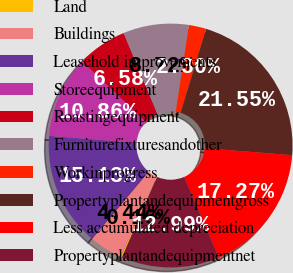Convert chart. <chart><loc_0><loc_0><loc_500><loc_500><pie_chart><fcel>Land<fcel>Buildings<fcel>Leasehold improvements<fcel>Storeequipment<fcel>Roastingequipment<fcel>Furniturefixturesandother<fcel>Workinprogress<fcel>Propertyplantandequipmentgross<fcel>Less accumulated depreciation<fcel>Propertyplantandequipmentnet<nl><fcel>0.16%<fcel>4.44%<fcel>15.14%<fcel>10.86%<fcel>6.58%<fcel>8.72%<fcel>2.3%<fcel>21.56%<fcel>17.28%<fcel>13.0%<nl></chart> 